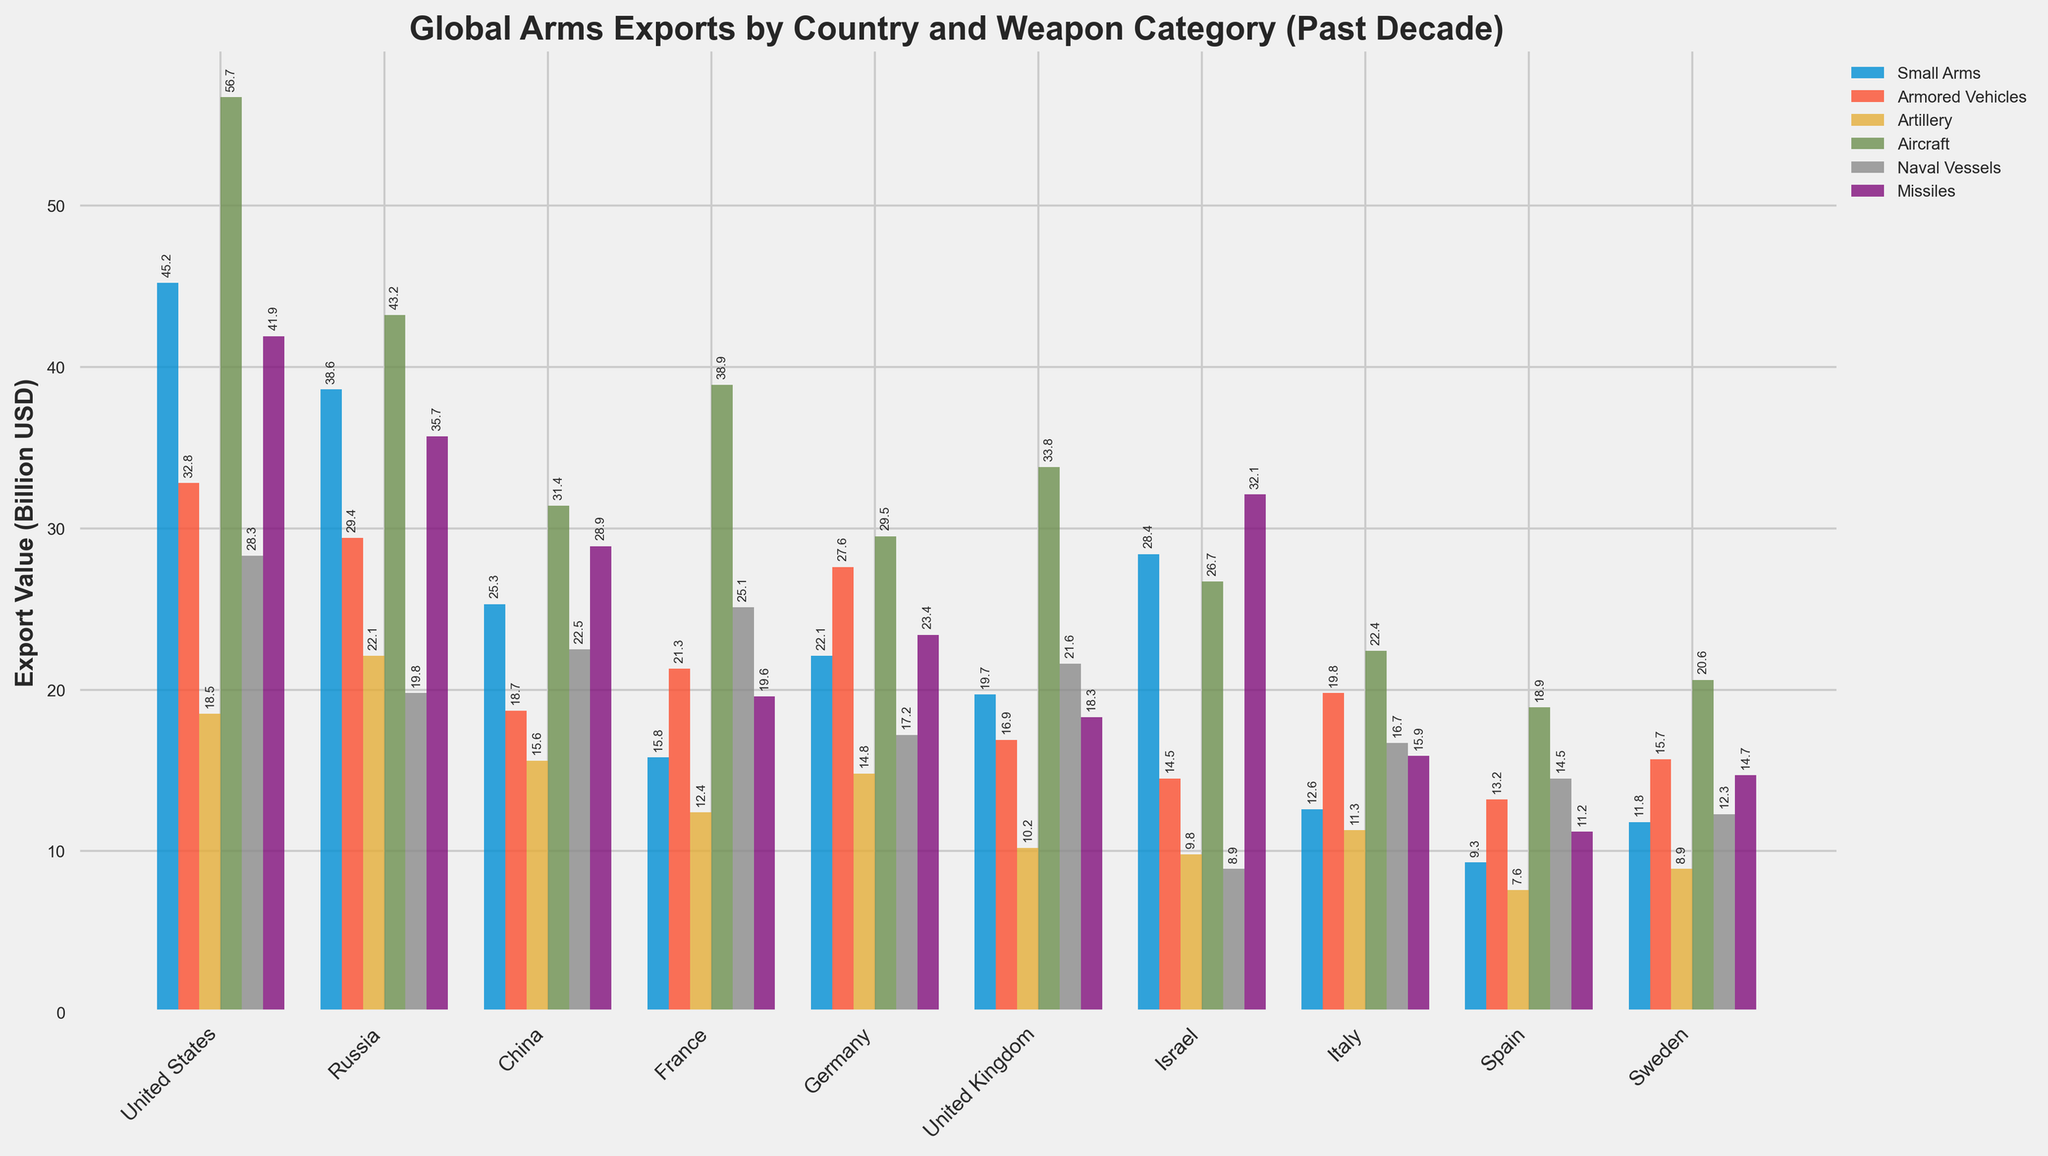Which country has the highest total export value in all weapon categories combined? Add the export values of each weapon category for all countries. The United States has the highest combined total: 45.2 + 32.8 + 18.5 + 56.7 + 28.3 + 41.9 = 223.4
Answer: United States Which weapon category has the lowest export value for Sweden? Compare the export values of all weapon categories for Sweden. The Artillery category has the lowest export value of 8.9
Answer: Artillery Which two countries have the smallest difference in their export values of Naval Vessels? Calculate the differences in Naval Vessel export values between each pair of countries. France and China have a difference of 25.1 - 22.5 = 2.6, the smallest difference.
Answer: France and China How much more does the United States export in Aircraft compared to Sweden? Subtract the Aircraft export value of Sweden from the United States: 56.7 - 20.6 = 36.1
Answer: 36.1 Which country has the highest export value in Missiles? Find the highest value in the Missiles column. The United States has the highest value of 41.9
Answer: United States Is the export value of Artillery for Germany greater than that of France? Compare the Artillery export values of Germany and France. Germany exports 14.8 while France exports 12.4, so Germany's value is greater.
Answer: Yes What's the average export value of Small Arms for the top three exporting countries in this category? Calculate the average of the Small Arms export values for the top three countries (United States: 45.2, Russia: 38.6, China: 25.3). The sum is 45.2 + 38.6 + 25.3 = 109.1, and the average is 109.1 / 3 = 36.37
Answer: 36.37 By how much does Russia's export value of Artillery exceed Italy's? Subtract Italy's Artillery export value from Russia's: 22.1 - 11.3 = 10.8
Answer: 10.8 Which country has consistently moderate levels of exports (neither the highest nor the lowest) across all categories? Analyze the bars' heights for each country to see which are consistently moderate within each category. Germany and United Kingdom have relatively moderate levels compared to extremes like the United States and Spain
Answer: Germany and United Kingdom Which weapon category shows the greatest variance in export values among all countries? Visually compare the spread and variation in the heights of bars for each weapon category. Aircraft shows the greatest variance, with values ranging from 56.7 (United States) to 18.9 (Spain), illustrating wider discrepancies.
Answer: Aircraft 